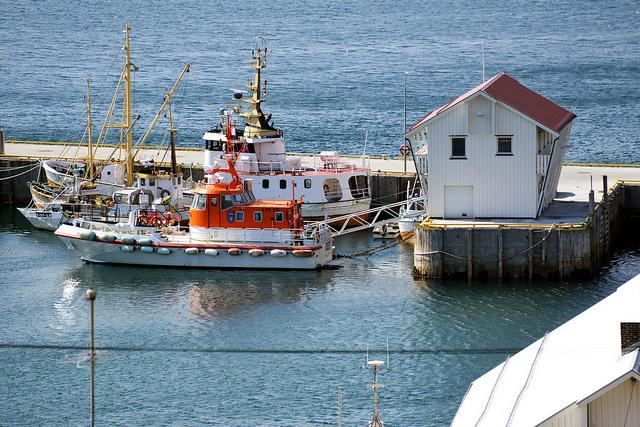What is above water? boat 